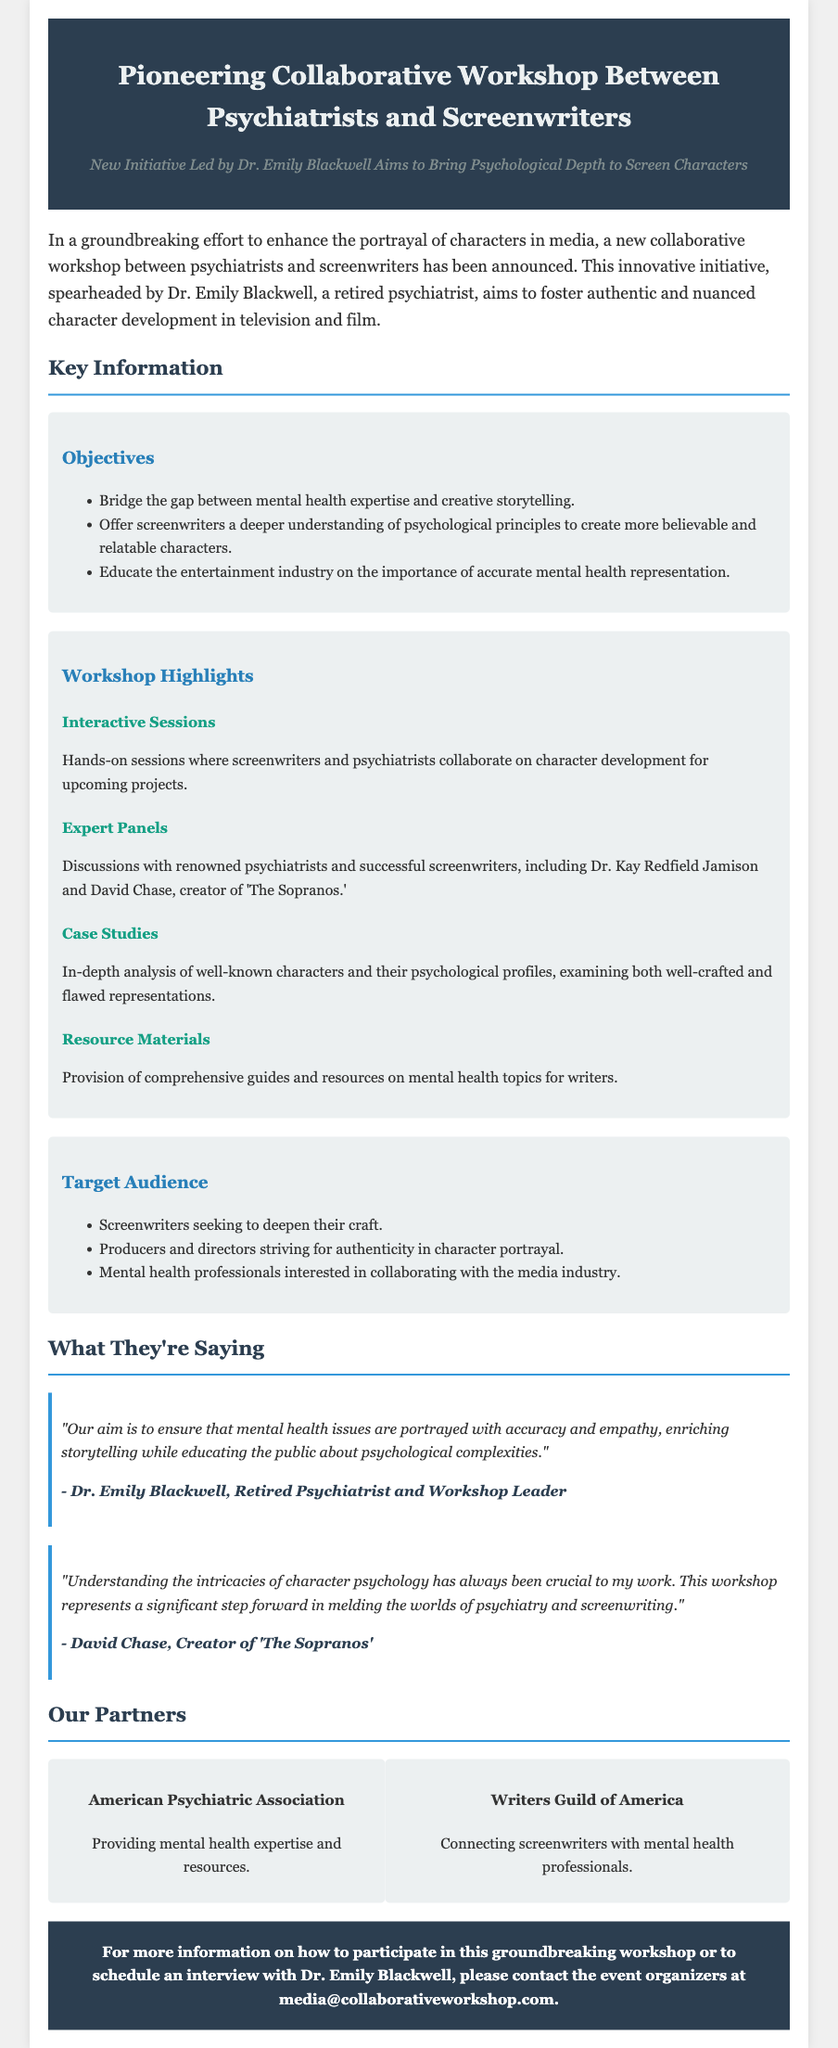What is the title of the workshop? The title of the workshop is stated at the beginning of the document and is "Pioneering Collaborative Workshop Between Psychiatrists and Screenwriters."
Answer: Pioneering Collaborative Workshop Between Psychiatrists and Screenwriters Who is the leader of the workshop? The leader of the workshop is introduced in the document, specifically noted as Dr. Emily Blackwell.
Answer: Dr. Emily Blackwell What is one objective of the workshop? The document lists the objectives, one of which is to bridge the gap between mental health expertise and creative storytelling.
Answer: Bridge the gap between mental health expertise and creative storytelling Who is a notable participant mentioned for the expert panels? The document provides names of notable participants that include Dr. Kay Redfield Jamison and David Chase.
Answer: David Chase What is a key highlight of the workshop? The document outlines several highlights, one of which involves interactive sessions where screenwriters and psychiatrists collaborate.
Answer: Interactive Sessions How many organizations are partnered in the workshop? The document mentions partnerships with two organizations: the American Psychiatric Association and the Writers Guild of America.
Answer: Two What type of audience is this workshop targeting? The document describes the target audience as screenwriters seeking to deepen their craft, producers, and mental health professionals.
Answer: Screenwriters seeking to deepen their craft What is a primary goal of the workshop as stated by Dr. Emily Blackwell? The statement reflects an aim to ensure that mental health issues are portrayed with accuracy and empathy.
Answer: Ensure that mental health issues are portrayed with accuracy and empathy What does the CTA section encourage readers to do? The CTA section encourages readers to contact the event organizers for more information or to schedule an interview.
Answer: Contact the event organizers for more information 